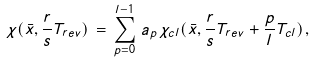Convert formula to latex. <formula><loc_0><loc_0><loc_500><loc_500>\chi ( \bar { x } , \frac { r } { s } T _ { r e v } ) \, = \, \sum _ { p = 0 } ^ { l - 1 } \, a _ { p } \, \chi _ { c l } ( \bar { x } , \frac { r } { s } T _ { r e v } + \frac { p } { l } T _ { c l } ) \, ,</formula> 